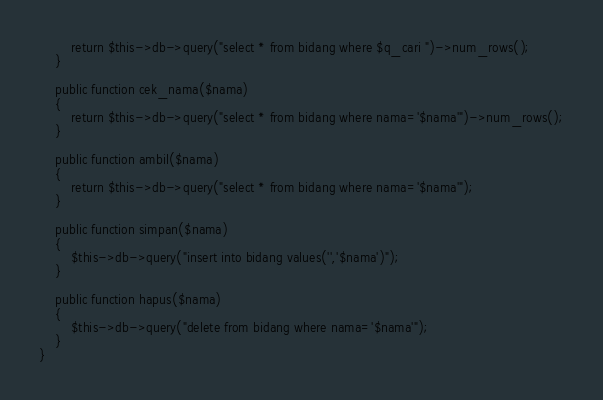<code> <loc_0><loc_0><loc_500><loc_500><_PHP_>        return $this->db->query("select * from bidang where $q_cari ")->num_rows();
    }

    public function cek_nama($nama)
    {
        return $this->db->query("select * from bidang where nama='$nama'")->num_rows();
    }

    public function ambil($nama)
    {
        return $this->db->query("select * from bidang where nama='$nama'");
    }

    public function simpan($nama)
    {
        $this->db->query("insert into bidang values('','$nama')");
    }

    public function hapus($nama)
    {
        $this->db->query("delete from bidang where nama='$nama'");
    }
}
</code> 